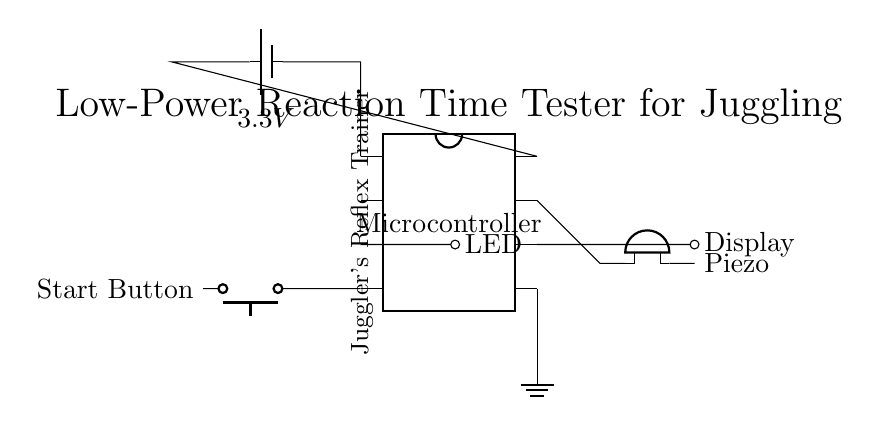What is the voltage supply for this circuit? The circuit is powered by a battery supplying a voltage of 3.3V, which is indicated next to the battery symbol in the circuit diagram.
Answer: 3.3V What components are connected to the microcontroller? The components connected to the microcontroller include an LED, a start button, a display, and a piezo buzzer, as shown by the lines leading from its pins to each component.
Answer: LED, Start Button, Display, Piezo Buzzer How many pins does the microcontroller have in this diagram? The diagram indicates that the microcontroller has 8 pins, which is designated by the num pins attribute in the dipchip notation.
Answer: 8 What is the function of the piezo buzzer in the circuit? The piezo buzzer serves as an audio output component that can produce sound, typically used to provide feedback, indicated by its placement connected to a pin on the microcontroller.
Answer: Audio Feedback Which component is used to initiate the reaction time test? The start button is the component used to initiate the reaction time test, as it is connected directly to one of the pins on the microcontroller and labeled as "Start Button."
Answer: Start Button Why is a low-power microcontroller selected for this circuit? A low-power microcontroller is selected to minimize energy consumption, which is essential in battery-operated devices, ensuring longer operation without frequent battery changes. This is critical in a portable device like a reaction time tester.
Answer: Minimize energy consumption 